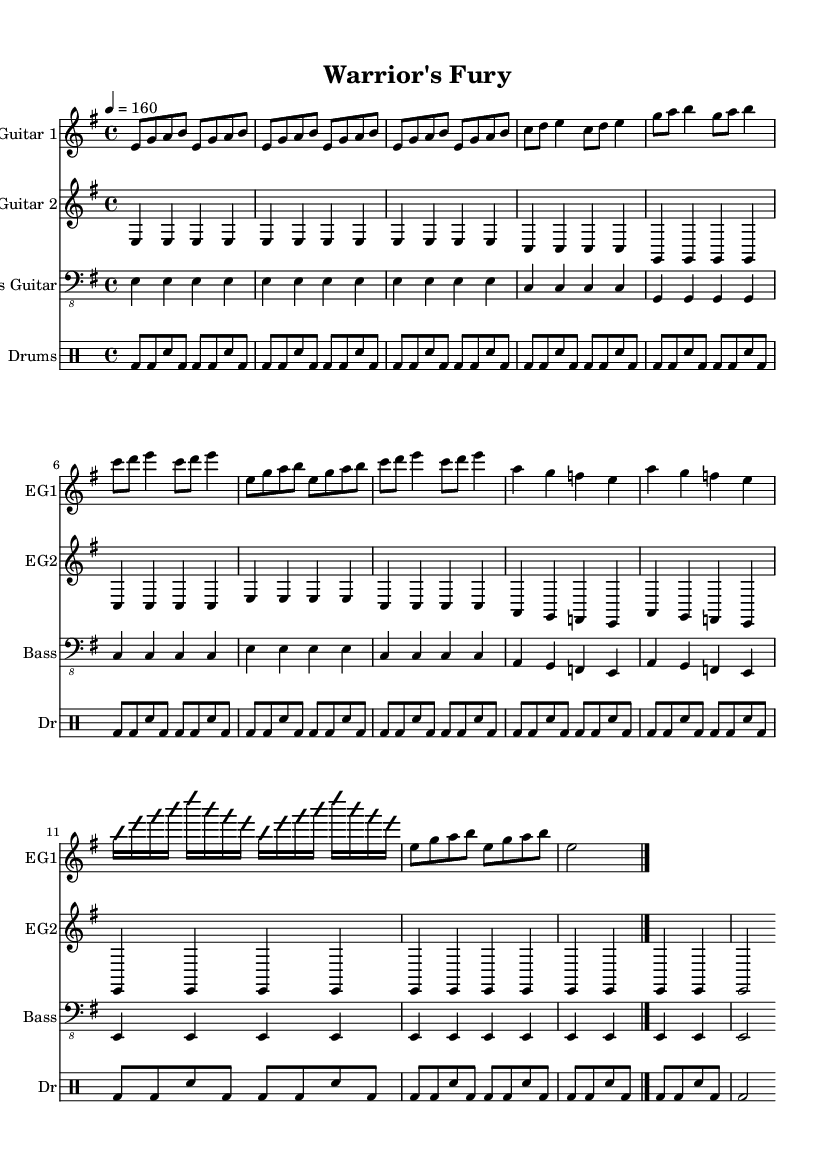What is the key signature of this music? The key signature is indicated by the sharp or flat symbols at the beginning of the staff. In this case, it shows one sharp, which designates the key of E minor (relative minor of G major).
Answer: E minor What is the time signature of this music? The time signature shows how many beats are in each measure and what note value gets one beat. It's at the beginning of the sheet music, indicating 4 beats per measure (4/4).
Answer: 4/4 What is the tempo marking for this piece? The tempo marking is found near the beginning of the piece and indicates how fast the music should be played. Here, it is set at 160 beats per minute.
Answer: 160 What is the title of the piece? The title is clearly noted at the top of the sheet music, providing the name for this specific composition, which is "Warrior's Fury."
Answer: Warrior's Fury How many different guitar parts are present in the score? Count the distinct parts for guitar listed in the score; there are two separate staves for electric guitars, indicating two different guitar parts.
Answer: 2 What type of drums are indicated in this score? The drumming pattern is notated in the drumming section showing how the notes are represented. The staff is labeled "Drums" indicating that it is for drum set.
Answer: Drums What thematic content is suggested by the title and musical elements? The title "Warrior's Fury" along with the aggressive metal style and fast tempo suggest themes of competition, battle, and a warrior mindset, characteristic of aggressive metal music.
Answer: Competition 